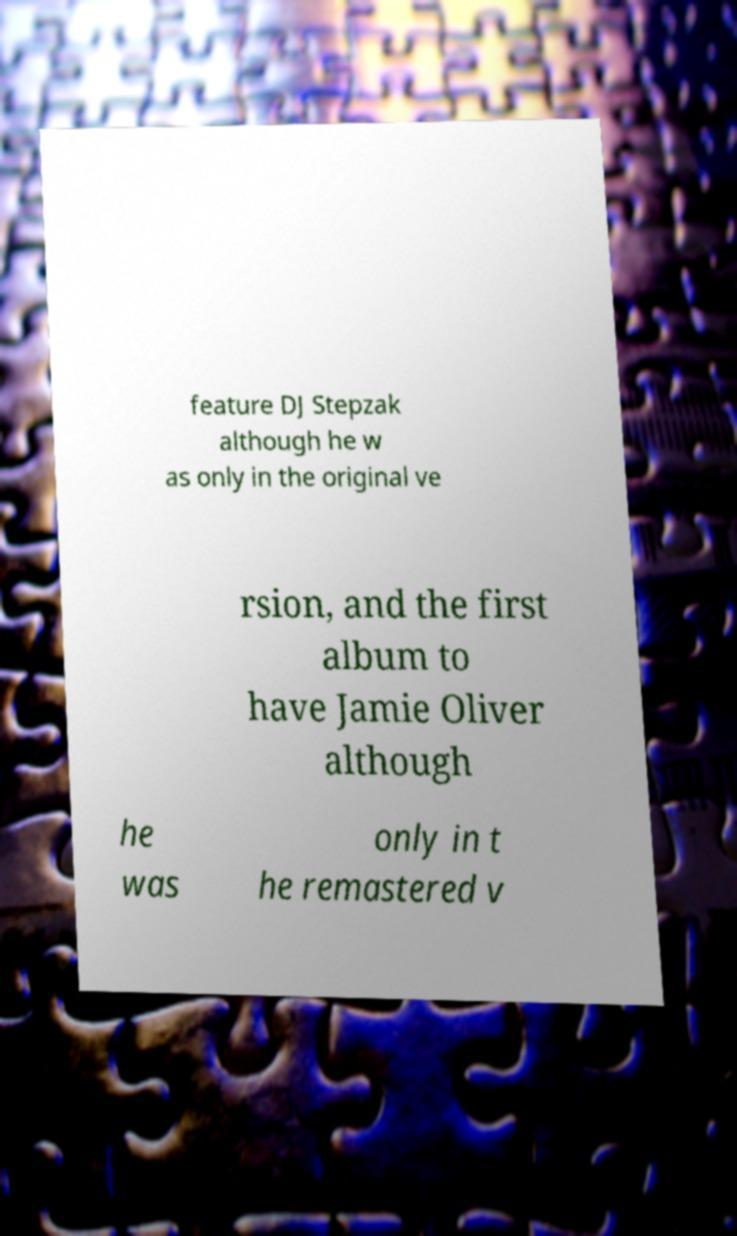Can you read and provide the text displayed in the image?This photo seems to have some interesting text. Can you extract and type it out for me? feature DJ Stepzak although he w as only in the original ve rsion, and the first album to have Jamie Oliver although he was only in t he remastered v 